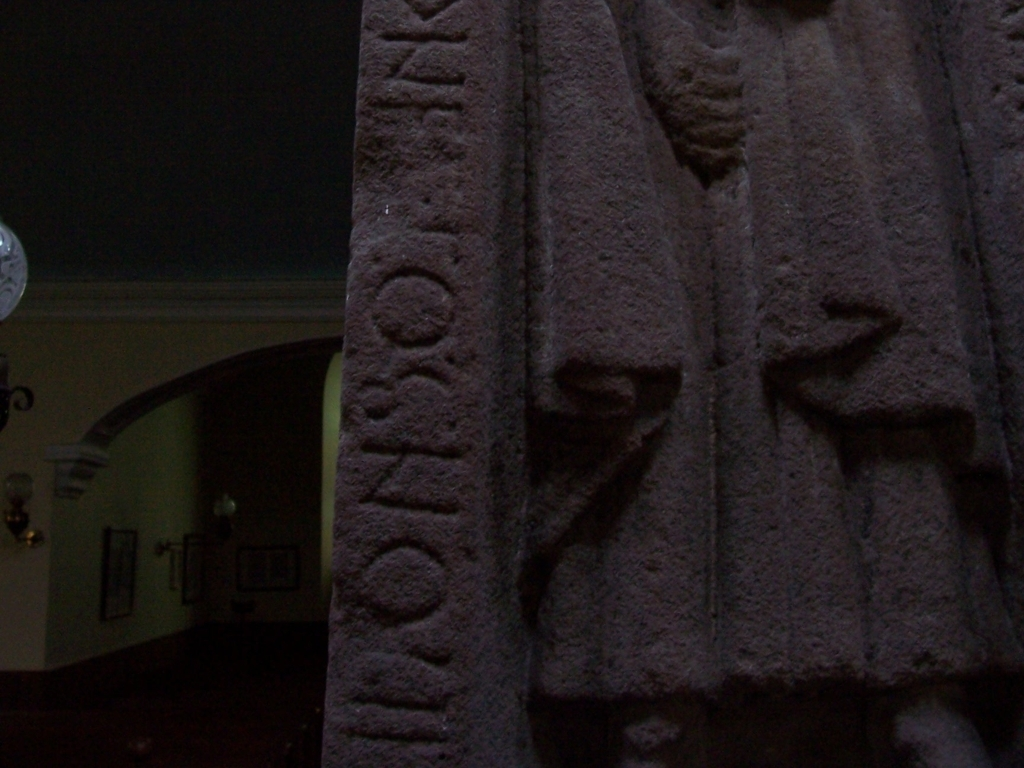What might this text and these carvings represent or signify? Without specific context, it's challenging to pinpoint the exact representation or significance. Generally, such inscriptions and relief carvings can depict important historical, religious, or cultural narratives. The text likely offers a clue, possibly naming a figure or a place, while the figures alongside might be depicting scenes associated with the text. 